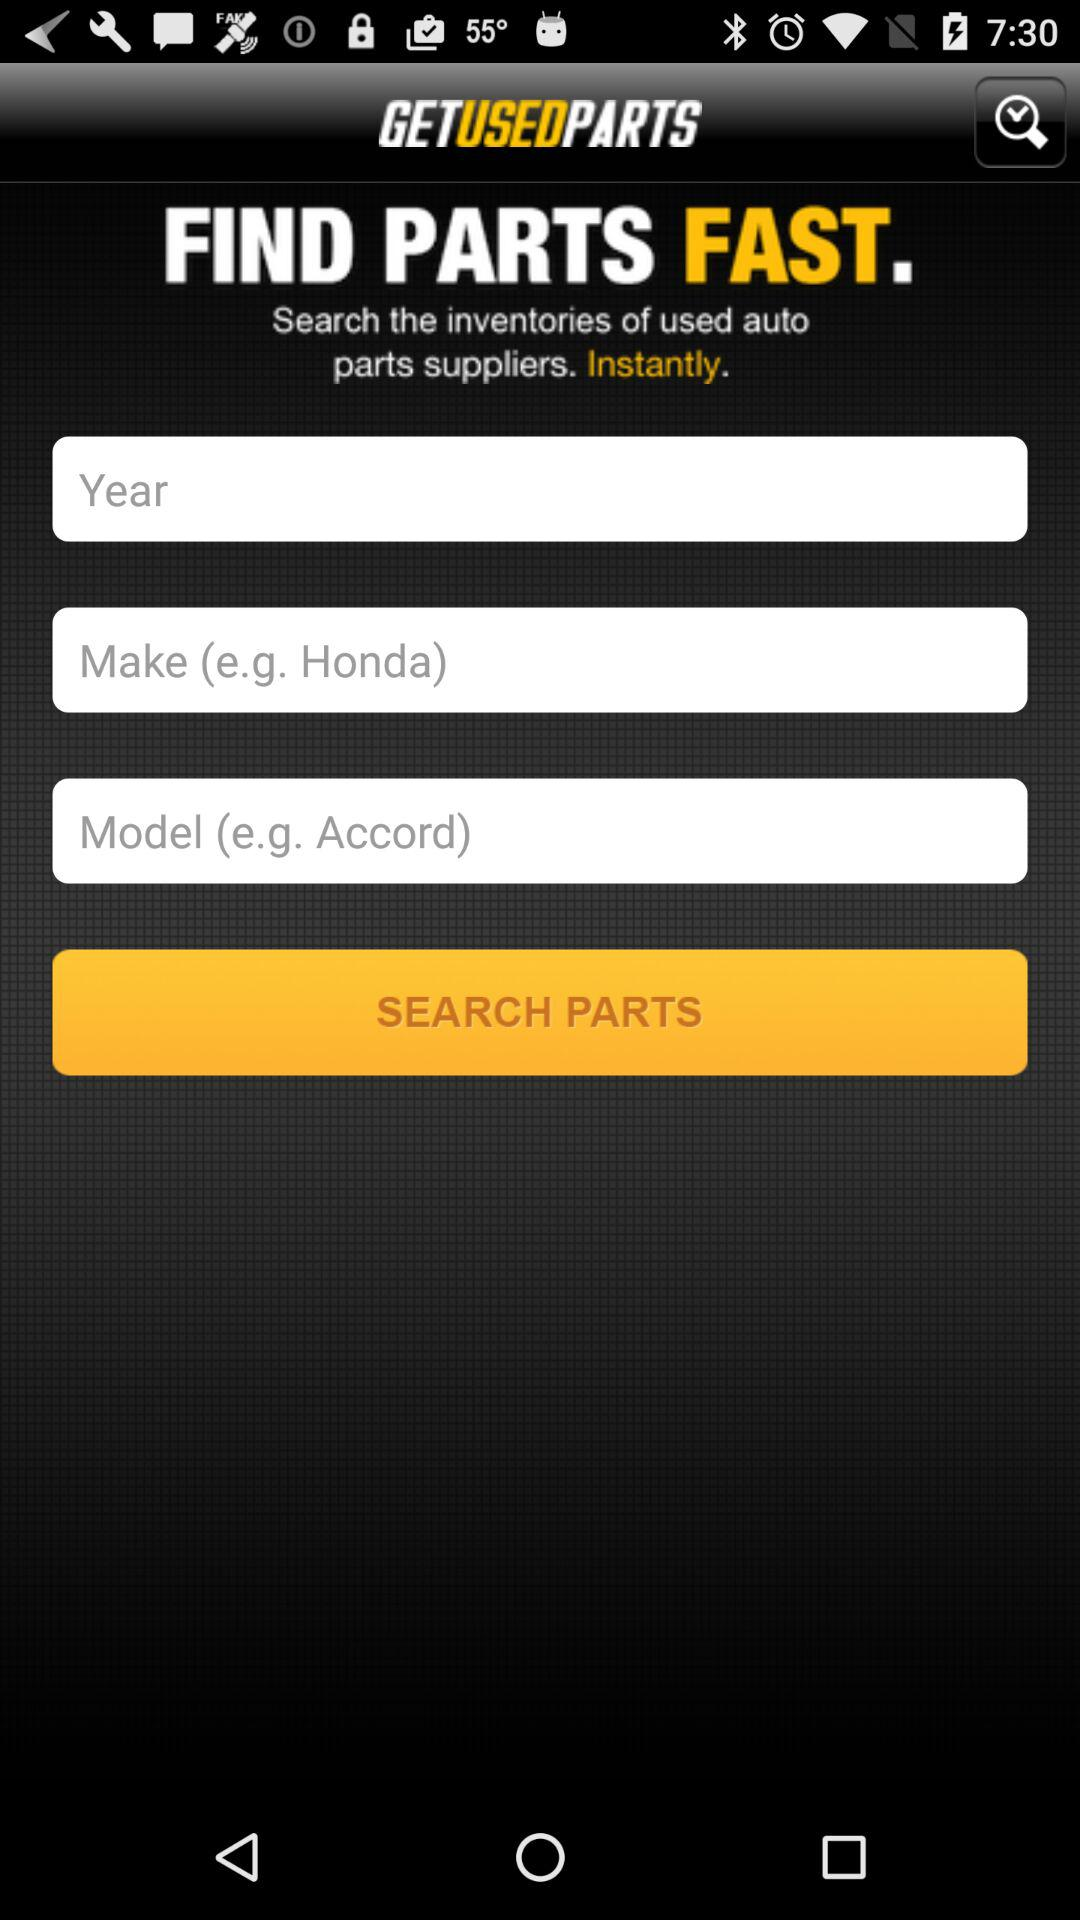How many text inputs are there for the user to enter information?
Answer the question using a single word or phrase. 3 